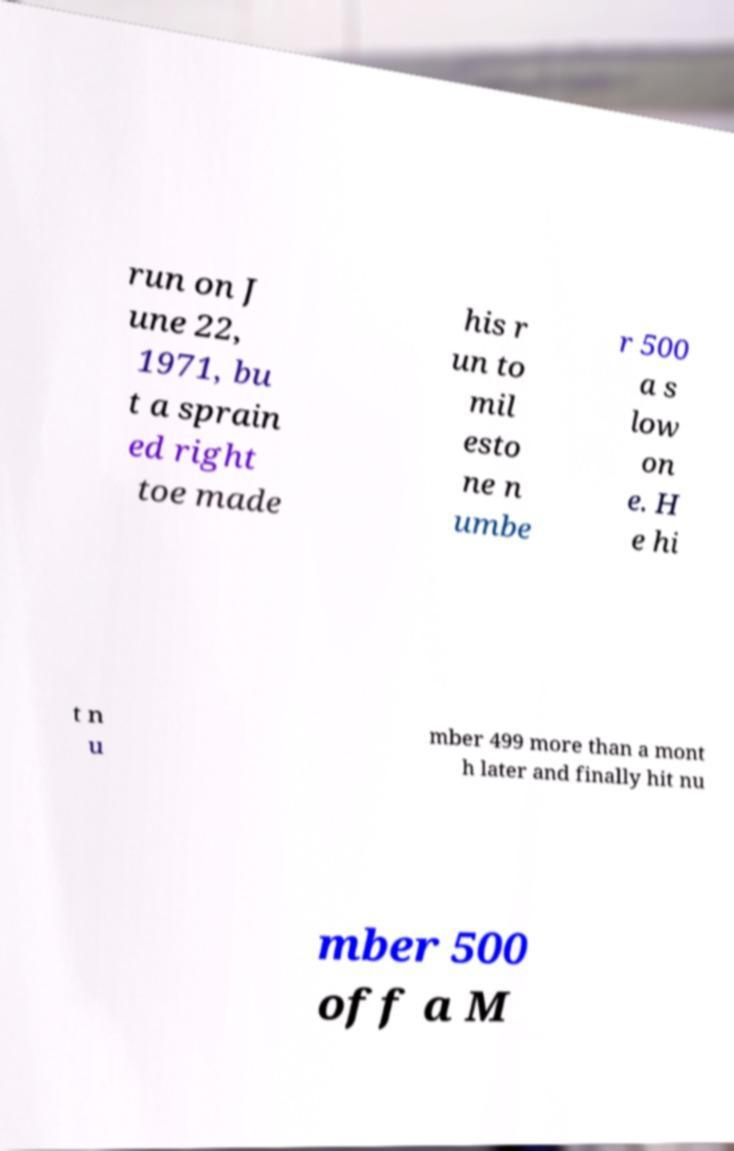Can you accurately transcribe the text from the provided image for me? run on J une 22, 1971, bu t a sprain ed right toe made his r un to mil esto ne n umbe r 500 a s low on e. H e hi t n u mber 499 more than a mont h later and finally hit nu mber 500 off a M 